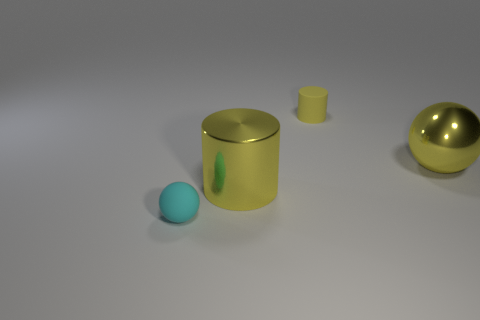Are there any big metal things to the right of the matte thing right of the tiny matte thing in front of the big yellow ball?
Provide a succinct answer. Yes. There is a yellow thing behind the yellow shiny sphere; is its size the same as the small cyan sphere?
Ensure brevity in your answer.  Yes. What number of gray metal cubes are the same size as the cyan matte ball?
Provide a succinct answer. 0. There is a sphere that is the same color as the tiny rubber cylinder; what is its size?
Your response must be concise. Large. Is the metallic cylinder the same color as the shiny sphere?
Your answer should be very brief. Yes. The tiny cyan object has what shape?
Offer a terse response. Sphere. Is there a small thing of the same color as the metallic cylinder?
Your response must be concise. Yes. Are there more big things that are right of the rubber sphere than large yellow metallic cylinders?
Your answer should be compact. Yes. There is a tiny cyan thing; is its shape the same as the yellow thing that is right of the yellow rubber cylinder?
Provide a short and direct response. Yes. Are there any red rubber cubes?
Give a very brief answer. No. 